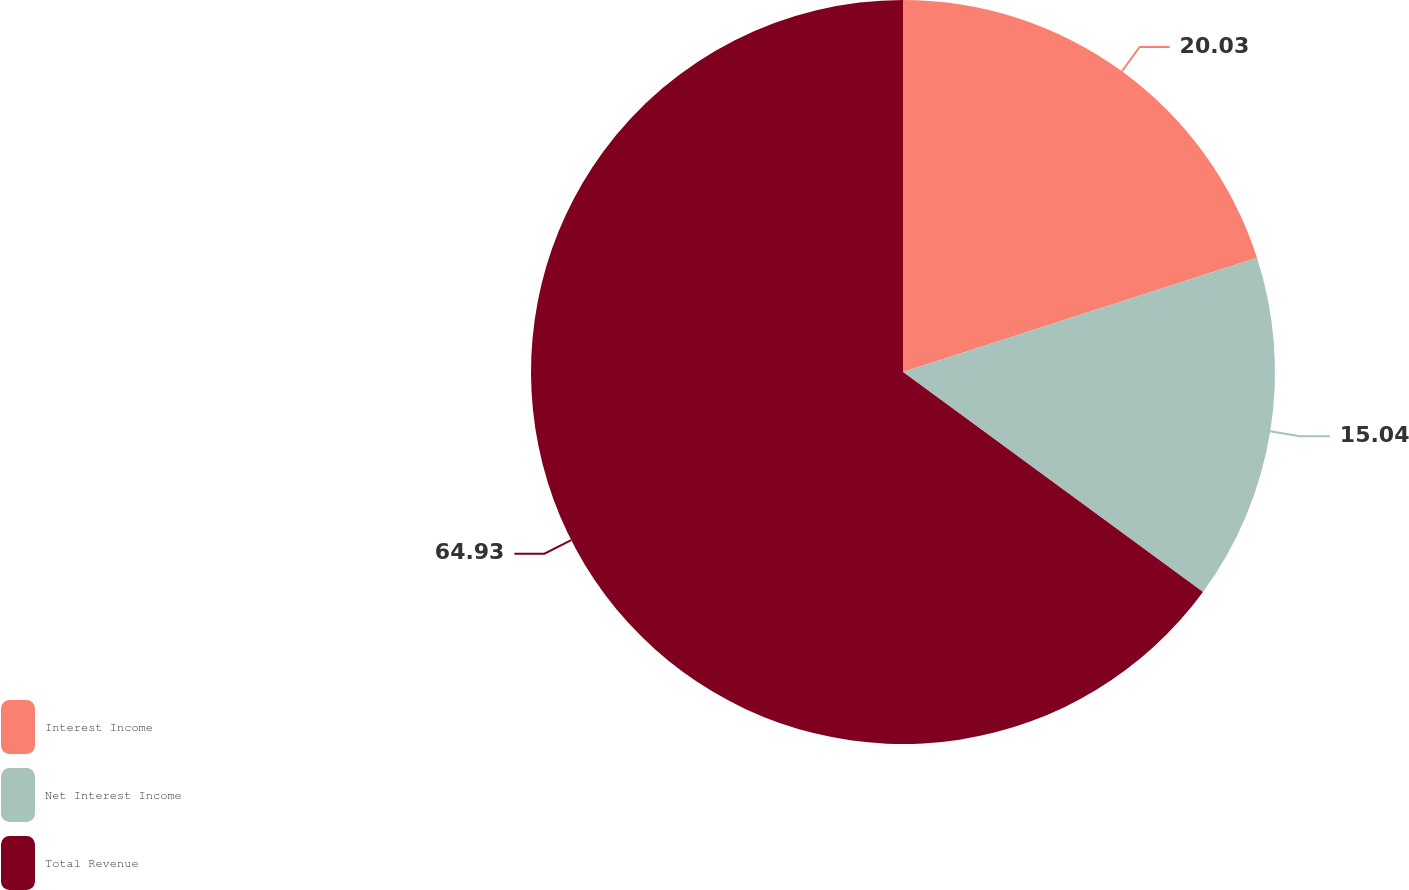<chart> <loc_0><loc_0><loc_500><loc_500><pie_chart><fcel>Interest Income<fcel>Net Interest Income<fcel>Total Revenue<nl><fcel>20.03%<fcel>15.04%<fcel>64.93%<nl></chart> 